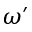<formula> <loc_0><loc_0><loc_500><loc_500>\omega ^ { \prime }</formula> 